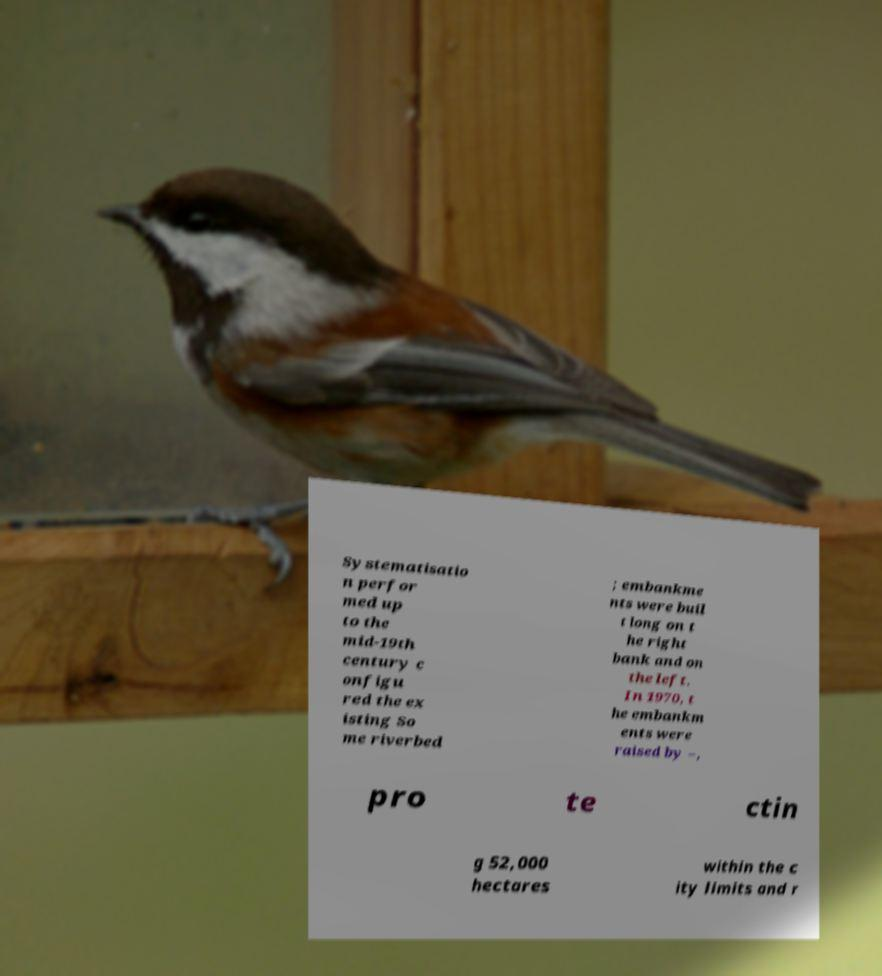Please identify and transcribe the text found in this image. Systematisatio n perfor med up to the mid-19th century c onfigu red the ex isting So me riverbed ; embankme nts were buil t long on t he right bank and on the left. In 1970, t he embankm ents were raised by –, pro te ctin g 52,000 hectares within the c ity limits and r 